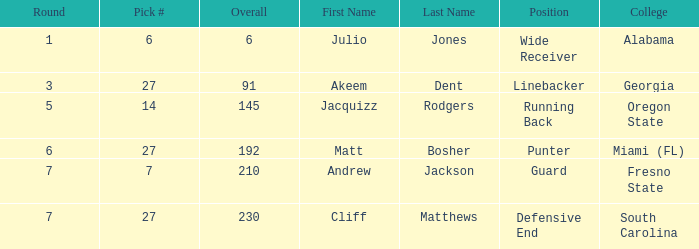Which name had more than 5 rounds and was a defensive end? Cliff Matthews. 